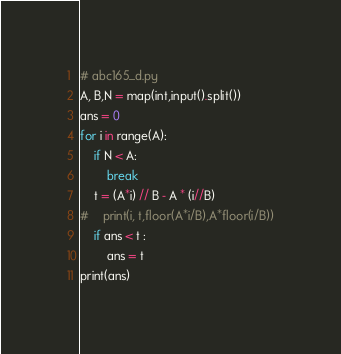<code> <loc_0><loc_0><loc_500><loc_500><_Python_># abc165_d.py
A, B,N = map(int,input().split())
ans = 0
for i in range(A):
    if N < A:
        break
    t = (A*i) // B - A * (i//B)
#    print(i, t,floor(A*i/B),A*floor(i/B))
    if ans < t :
        ans = t
print(ans)</code> 